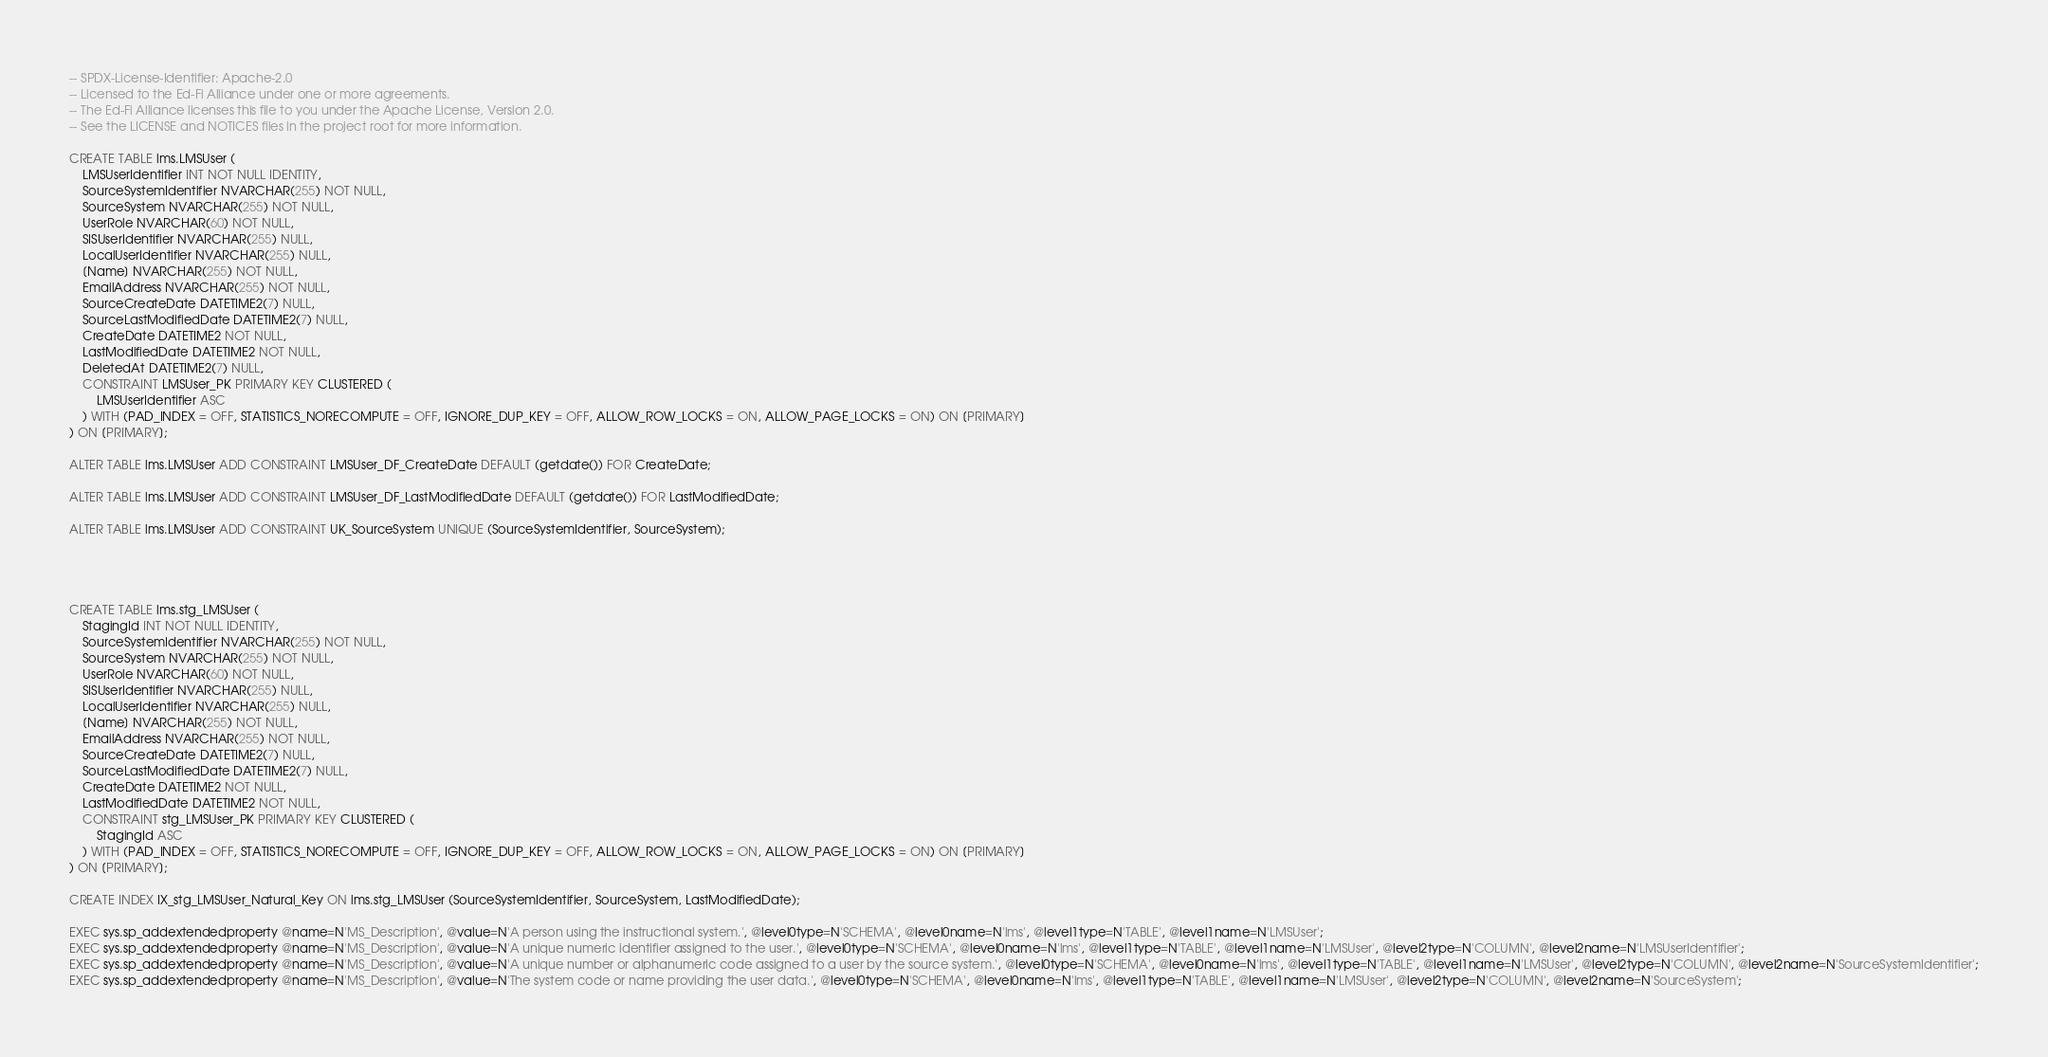<code> <loc_0><loc_0><loc_500><loc_500><_SQL_>-- SPDX-License-Identifier: Apache-2.0
-- Licensed to the Ed-Fi Alliance under one or more agreements.
-- The Ed-Fi Alliance licenses this file to you under the Apache License, Version 2.0.
-- See the LICENSE and NOTICES files in the project root for more information.

CREATE TABLE lms.LMSUser (
    LMSUserIdentifier INT NOT NULL IDENTITY,
    SourceSystemIdentifier NVARCHAR(255) NOT NULL,
    SourceSystem NVARCHAR(255) NOT NULL,
    UserRole NVARCHAR(60) NOT NULL,
    SISUserIdentifier NVARCHAR(255) NULL,
    LocalUserIdentifier NVARCHAR(255) NULL,
    [Name] NVARCHAR(255) NOT NULL,
    EmailAddress NVARCHAR(255) NOT NULL,
    SourceCreateDate DATETIME2(7) NULL,
    SourceLastModifiedDate DATETIME2(7) NULL,
    CreateDate DATETIME2 NOT NULL,
    LastModifiedDate DATETIME2 NOT NULL,
    DeletedAt DATETIME2(7) NULL,
    CONSTRAINT LMSUser_PK PRIMARY KEY CLUSTERED (
        LMSUserIdentifier ASC
    ) WITH (PAD_INDEX = OFF, STATISTICS_NORECOMPUTE = OFF, IGNORE_DUP_KEY = OFF, ALLOW_ROW_LOCKS = ON, ALLOW_PAGE_LOCKS = ON) ON [PRIMARY]
) ON [PRIMARY];

ALTER TABLE lms.LMSUser ADD CONSTRAINT LMSUser_DF_CreateDate DEFAULT (getdate()) FOR CreateDate;

ALTER TABLE lms.LMSUser ADD CONSTRAINT LMSUser_DF_LastModifiedDate DEFAULT (getdate()) FOR LastModifiedDate;

ALTER TABLE lms.LMSUser ADD CONSTRAINT UK_SourceSystem UNIQUE (SourceSystemIdentifier, SourceSystem);




CREATE TABLE lms.stg_LMSUser (
    StagingId INT NOT NULL IDENTITY,
    SourceSystemIdentifier NVARCHAR(255) NOT NULL,
    SourceSystem NVARCHAR(255) NOT NULL,
    UserRole NVARCHAR(60) NOT NULL,
    SISUserIdentifier NVARCHAR(255) NULL,
    LocalUserIdentifier NVARCHAR(255) NULL,
    [Name] NVARCHAR(255) NOT NULL,
    EmailAddress NVARCHAR(255) NOT NULL,
    SourceCreateDate DATETIME2(7) NULL,
    SourceLastModifiedDate DATETIME2(7) NULL,
    CreateDate DATETIME2 NOT NULL,
    LastModifiedDate DATETIME2 NOT NULL,
    CONSTRAINT stg_LMSUser_PK PRIMARY KEY CLUSTERED (
        StagingId ASC
    ) WITH (PAD_INDEX = OFF, STATISTICS_NORECOMPUTE = OFF, IGNORE_DUP_KEY = OFF, ALLOW_ROW_LOCKS = ON, ALLOW_PAGE_LOCKS = ON) ON [PRIMARY]
) ON [PRIMARY];

CREATE INDEX IX_stg_LMSUser_Natural_Key ON lms.stg_LMSUser (SourceSystemIdentifier, SourceSystem, LastModifiedDate);

EXEC sys.sp_addextendedproperty @name=N'MS_Description', @value=N'A person using the instructional system.', @level0type=N'SCHEMA', @level0name=N'lms', @level1type=N'TABLE', @level1name=N'LMSUser';
EXEC sys.sp_addextendedproperty @name=N'MS_Description', @value=N'A unique numeric identifier assigned to the user.', @level0type=N'SCHEMA', @level0name=N'lms', @level1type=N'TABLE', @level1name=N'LMSUser', @level2type=N'COLUMN', @level2name=N'LMSUserIdentifier';
EXEC sys.sp_addextendedproperty @name=N'MS_Description', @value=N'A unique number or alphanumeric code assigned to a user by the source system.', @level0type=N'SCHEMA', @level0name=N'lms', @level1type=N'TABLE', @level1name=N'LMSUser', @level2type=N'COLUMN', @level2name=N'SourceSystemIdentifier';
EXEC sys.sp_addextendedproperty @name=N'MS_Description', @value=N'The system code or name providing the user data.', @level0type=N'SCHEMA', @level0name=N'lms', @level1type=N'TABLE', @level1name=N'LMSUser', @level2type=N'COLUMN', @level2name=N'SourceSystem';</code> 